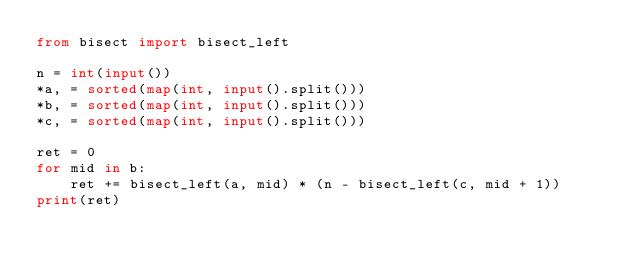Convert code to text. <code><loc_0><loc_0><loc_500><loc_500><_Python_>from bisect import bisect_left

n = int(input())
*a, = sorted(map(int, input().split()))
*b, = sorted(map(int, input().split()))
*c, = sorted(map(int, input().split()))

ret = 0
for mid in b:
    ret += bisect_left(a, mid) * (n - bisect_left(c, mid + 1))
print(ret)
</code> 